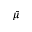Convert formula to latex. <formula><loc_0><loc_0><loc_500><loc_500>\bar { \mu }</formula> 